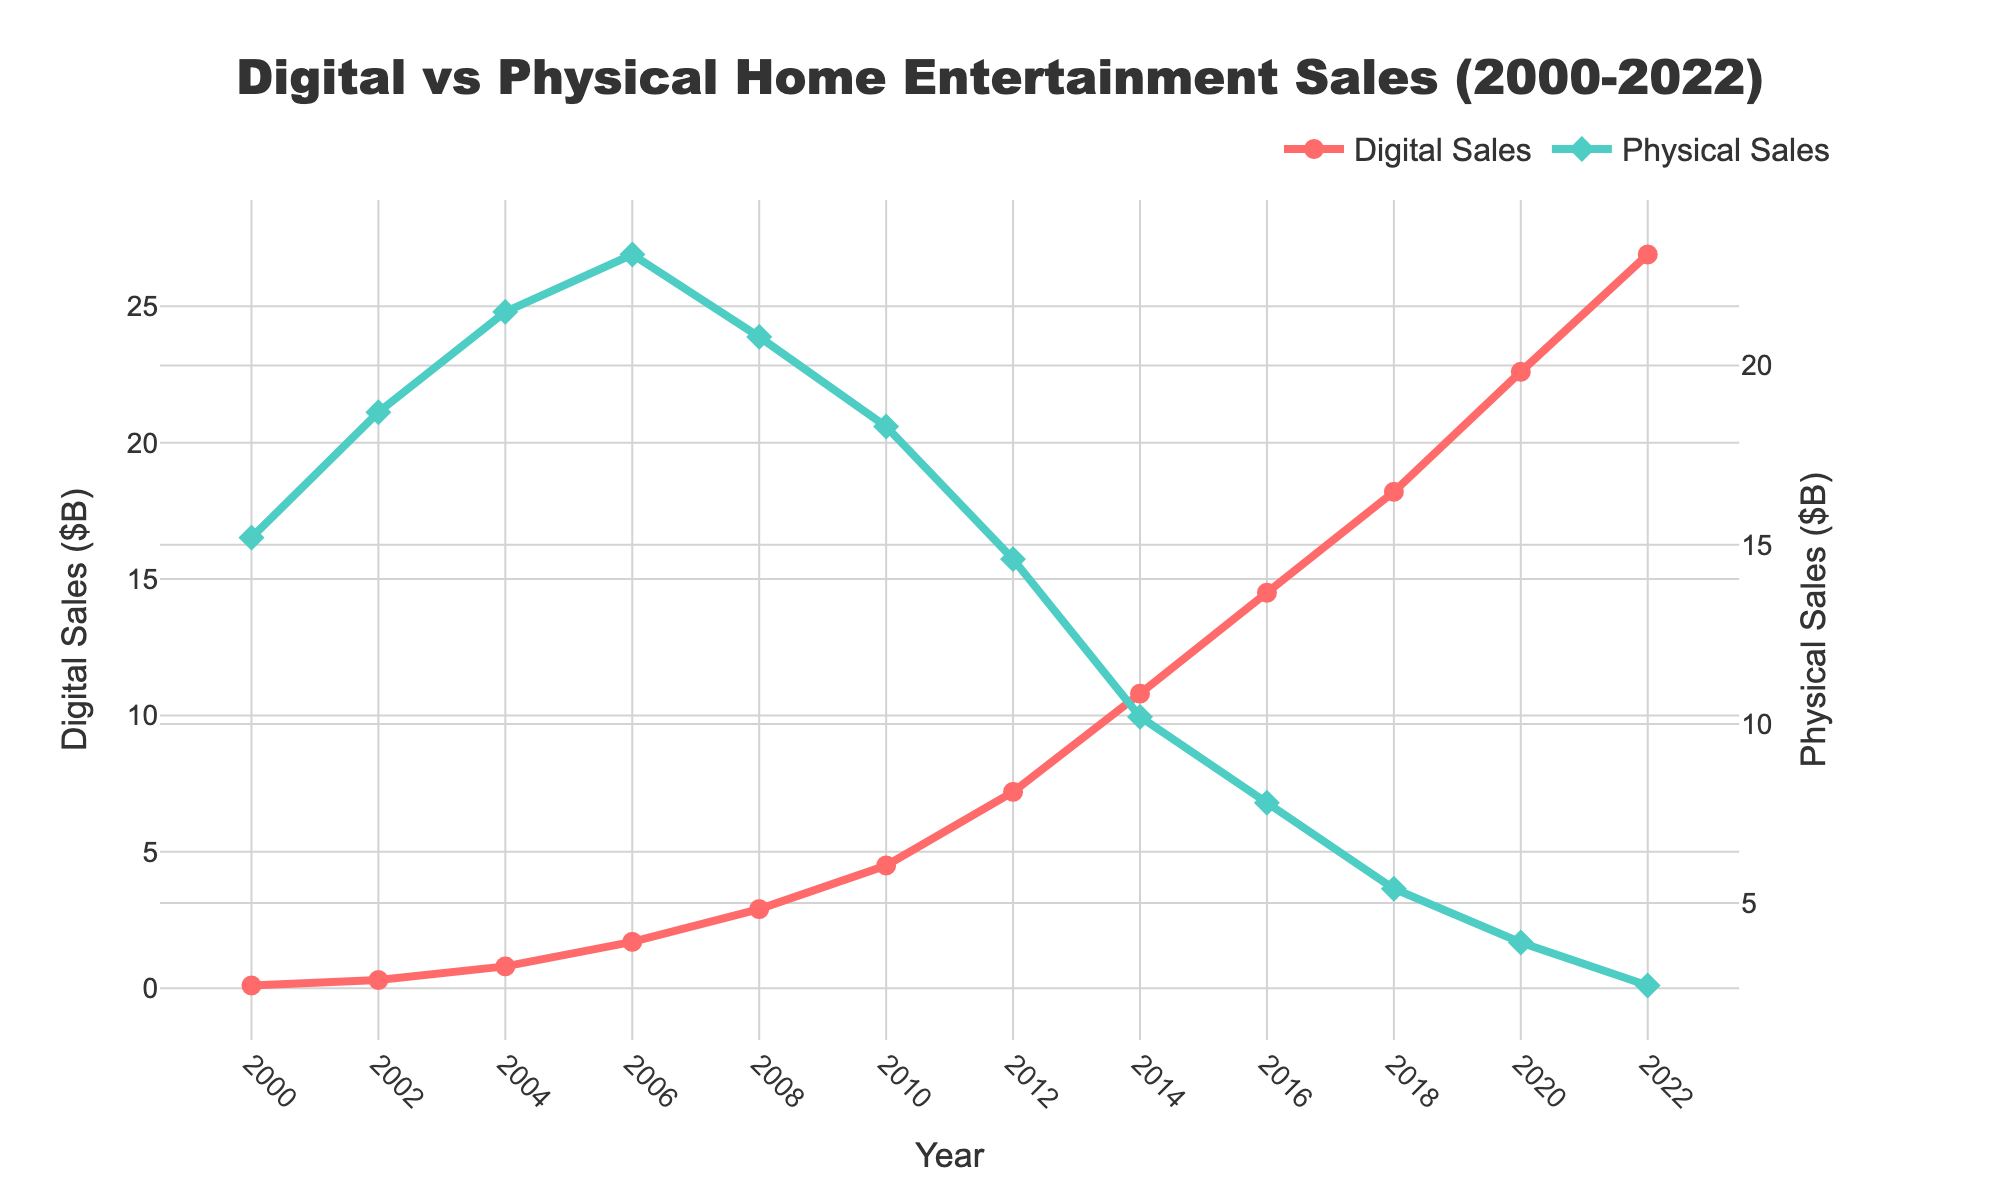What was the trend in digital sales from 2000 to 2022? To identify the trend in digital sales, look at the line representing digital sales from 2000 to 2022. Notice that the value consistently rises from 2000 ($0.1B) to 2022 ($26.9B), reflecting a clear upward trend.
Answer: Upward trend How have physical sales changed from 2006 to 2022? Look at the line for physical sales between 2006 and 2022. Physical sales peaked at $23.1B in 2006 and then gradually declined to $2.7B in 2022.
Answer: Declined What year did digital sales first surpass physical sales? Observe where the digital sales line crosses above the physical sales line. This crossover occurs between 2014 and 2016. In 2016, digital sales ($14.5B) are greater than physical sales ($7.8B), indicating the crossover has happened by 2016.
Answer: 2016 Which year had the highest digital sales and by how much? Look at the digital sales line to find the highest point, which is in 2022 at $26.9B.
Answer: 2022, $26.9B Which year had the highest physical sales and by how much? Identify the highest point on the physical sales line, which occurs in 2006 at $23.1B.
Answer: 2006, $23.1B What was the difference between digital and physical sales in 2018? In 2018, digital sales were $18.2B, and physical sales were $5.4B. Subtract physical sales from digital sales: $18.2B - $5.4B = $12.8B.
Answer: $12.8B What is the overall trend difference between digital and physical sales from 2000 to 2022? From 2000 to 2022, digital sales have shown an upward trend, increasing from $0.1B to $26.9B. In contrast, physical sales have exhibited a downward trend, decreasing from $15.2B to $2.7B over the same period.
Answer: Digital increased, Physical decreased During which 4-year interval did digital sales increase the most, and by how much? Examine the digital sales line and look for the largest vertical jump within any 4-year period. From 2012 to 2016, digital sales increased from $7.2B to $14.5B. The increase is $14.5B - $7.2B = $7.3B.
Answer: 2012-2016, $7.3B Compare the rate of decrease in physical sales between 2010 and 2014 with the rate of increase in digital sales during the same period. Between 2010 and 2014, physical sales decreased from $18.3B to $10.2B, a decrease of $8.1B. Digital sales increased from $4.5B to $10.8B, an increase of $6.3B. Thus, the physical sales decrease is faster than the digital sales increase by $8.1B - $6.3B = $1.8B.
Answer: Physical decrease faster by $1.8B By how much did physical sales surpass digital sales in 2002? In 2002, physical sales were $18.7B, and digital sales were $0.3B. The difference is $18.7B - $0.3B = $18.4B.
Answer: $18.4B 